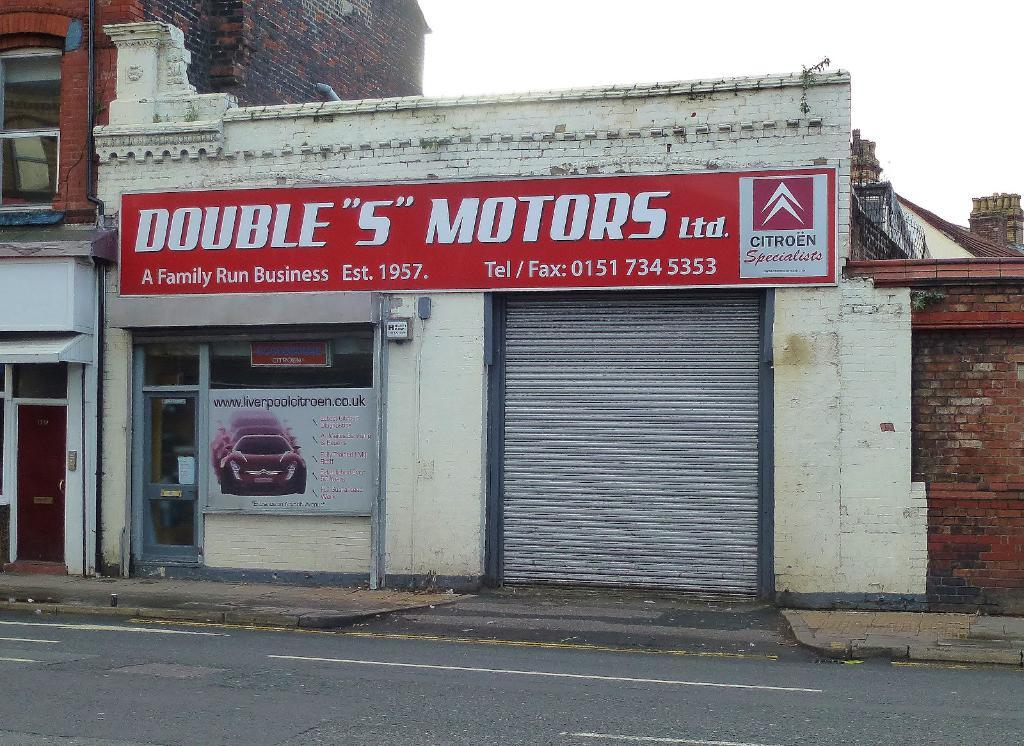What is located at the bottom of the image? There is a road at the bottom of the image. What can be seen in the middle of the image? There are buildings in the middle of the image. What is visible at the top of the image? The sky is visible at the top of the image. What type of business is being conducted in the church in the image? There is no church present in the image, and therefore no business can be conducted in it. What kind of loaf can be seen in the image? There is no loaf present in the image. 